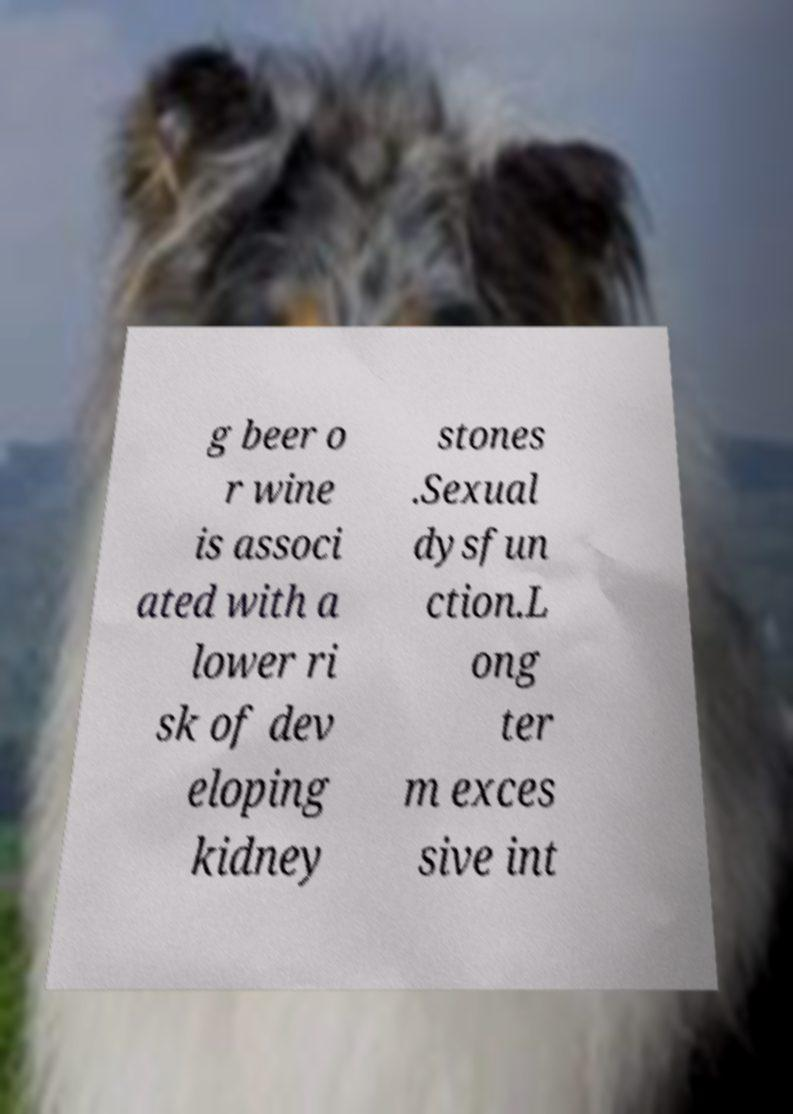For documentation purposes, I need the text within this image transcribed. Could you provide that? g beer o r wine is associ ated with a lower ri sk of dev eloping kidney stones .Sexual dysfun ction.L ong ter m exces sive int 